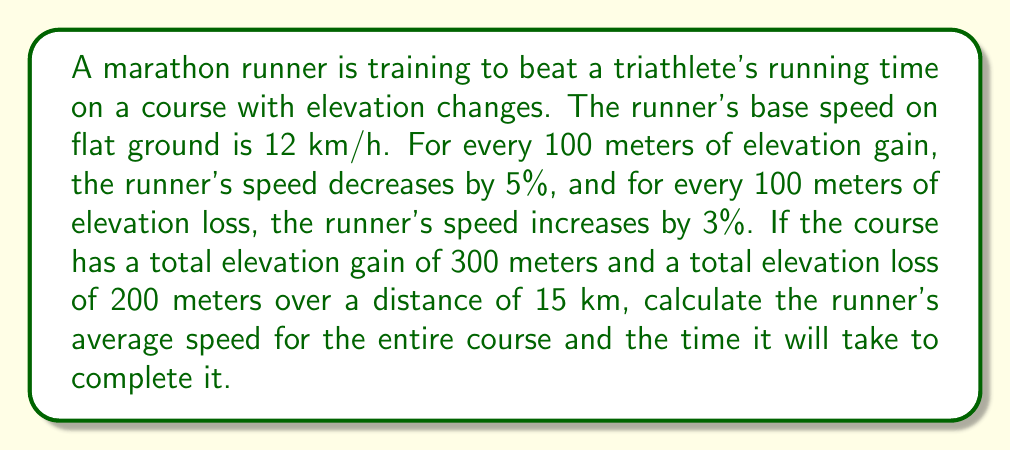Solve this math problem. Let's break this problem down into steps:

1. Calculate the speed changes due to elevation gain and loss:
   - Elevation gain: 300 m = 3 × 100 m
   - Speed decrease: $3 \times 5\% = 15\%$
   - Elevation loss: 200 m = 2 × 100 m
   - Speed increase: $2 \times 3\% = 6\%$

2. Calculate the net speed change:
   $\text{Net speed change} = -15\% + 6\% = -9\%$

3. Calculate the adjusted speed:
   $\text{Adjusted speed} = 12 \text{ km/h} \times (1 - 0.09) = 12 \times 0.91 = 10.92 \text{ km/h}$

4. Calculate the time to complete the course:
   $$\text{Time} = \frac{\text{Distance}}{\text{Speed}} = \frac{15 \text{ km}}{10.92 \text{ km/h}} = 1.374 \text{ hours}$$

5. Convert time to hours and minutes:
   $1.374 \text{ hours} = 1 \text{ hour and } 0.374 \times 60 = 22.44 \text{ minutes}$

Therefore, the runner's average speed for the entire course is 10.92 km/h, and it will take approximately 1 hour and 22 minutes to complete the 15 km course.
Answer: Average speed: 10.92 km/h
Time to complete the course: 1 hour and 22 minutes 